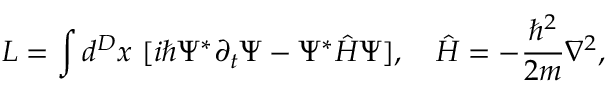<formula> <loc_0><loc_0><loc_500><loc_500>L = \int d ^ { D } x [ i \hbar { \Psi } ^ { * } \partial _ { t } \Psi - \Psi ^ { * } \hat { H } \Psi ] , \hat { H } = - \frac { \hbar { ^ } { 2 } } { 2 m } \nabla ^ { 2 } ,</formula> 